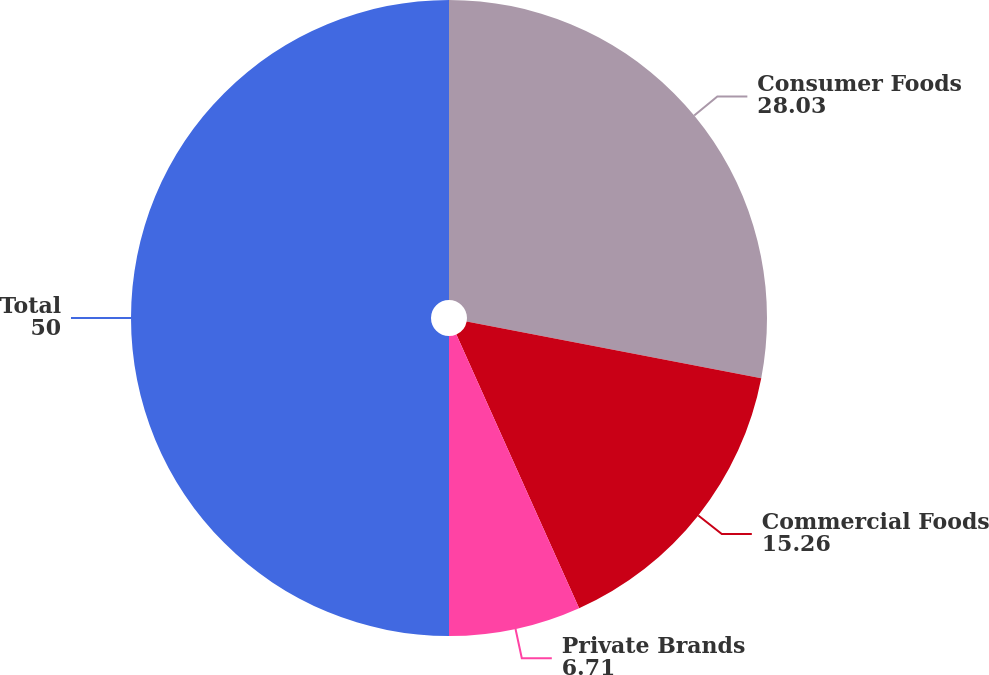Convert chart. <chart><loc_0><loc_0><loc_500><loc_500><pie_chart><fcel>Consumer Foods<fcel>Commercial Foods<fcel>Private Brands<fcel>Total<nl><fcel>28.03%<fcel>15.26%<fcel>6.71%<fcel>50.0%<nl></chart> 